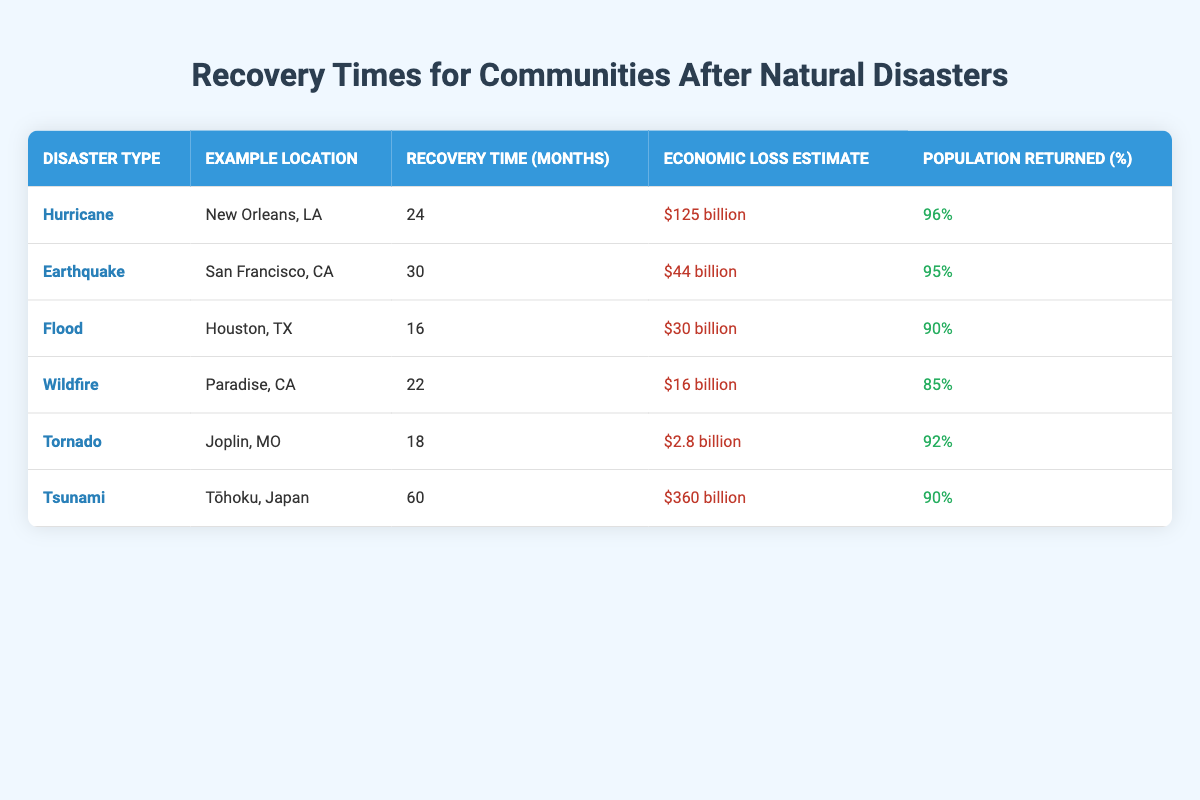What is the recovery time for floods? The table shows the recovery time for floods as 16 months located in Houston, TX.
Answer: 16 months Which disaster type has the highest economic loss estimate? By comparing the economic loss estimates in the table, the tsunami has the highest estimate at $360 billion.
Answer: Tsunami What is the average recovery time for tornadoes and wildfires? The recovery time for tornadoes is 18 months, and for wildfires, it is 22 months. The average is (18 + 22) / 2 = 20 months.
Answer: 20 months Did Paradise, CA recover a higher percentage of its population than Houston, TX? Paradise, CA had a population return of 85%, while Houston, TX had 90%. Therefore, Paradise did not recover a higher percentage.
Answer: No How many months longer does it take to recover from a tsunami compared to a flood? The recovery time for a tsunami is 60 months, and for a flood, it is 16 months. The difference is 60 - 16 = 44 months.
Answer: 44 months What percentage of the population returned after the earthquake in San Francisco, CA? Referring to the table, after the earthquake, 95% of the population returned in San Francisco, CA.
Answer: 95% Is the recovery time for hurricanes shorter than that for earthquakes? The recovery time for hurricanes is 24 months and for earthquakes is 30 months. Since 24 months is less than 30 months, the statement is true.
Answer: Yes What is the economic loss estimate for Joplin, MO compared to Houston, TX? The economic loss estimate for Joplin, MO is $2.8 billion, and for Houston, TX, it is $30 billion. Therefore, Joplin's estimate is significantly lower.
Answer: Lower How many total months are required for recovery for all disaster types listed in the table? The recovery times are 24 + 30 + 16 + 22 + 18 + 60 = 180 months.
Answer: 180 months 